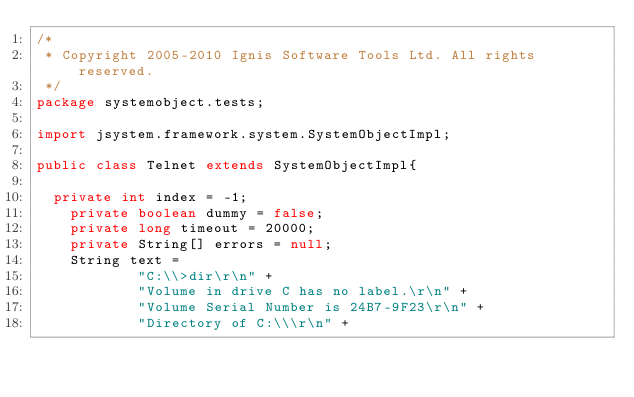Convert code to text. <code><loc_0><loc_0><loc_500><loc_500><_Java_>/*
 * Copyright 2005-2010 Ignis Software Tools Ltd. All rights reserved.
 */
package systemobject.tests;

import jsystem.framework.system.SystemObjectImpl;

public class Telnet extends SystemObjectImpl{
    
	private int index = -1;
    private boolean dummy = false;
    private long timeout = 20000;
    private String[] errors = null;
    String text =
            "C:\\>dir\r\n" +
            "Volume in drive C has no label.\r\n" +
            "Volume Serial Number is 24B7-9F23\r\n" +
            "Directory of C:\\\r\n" +</code> 